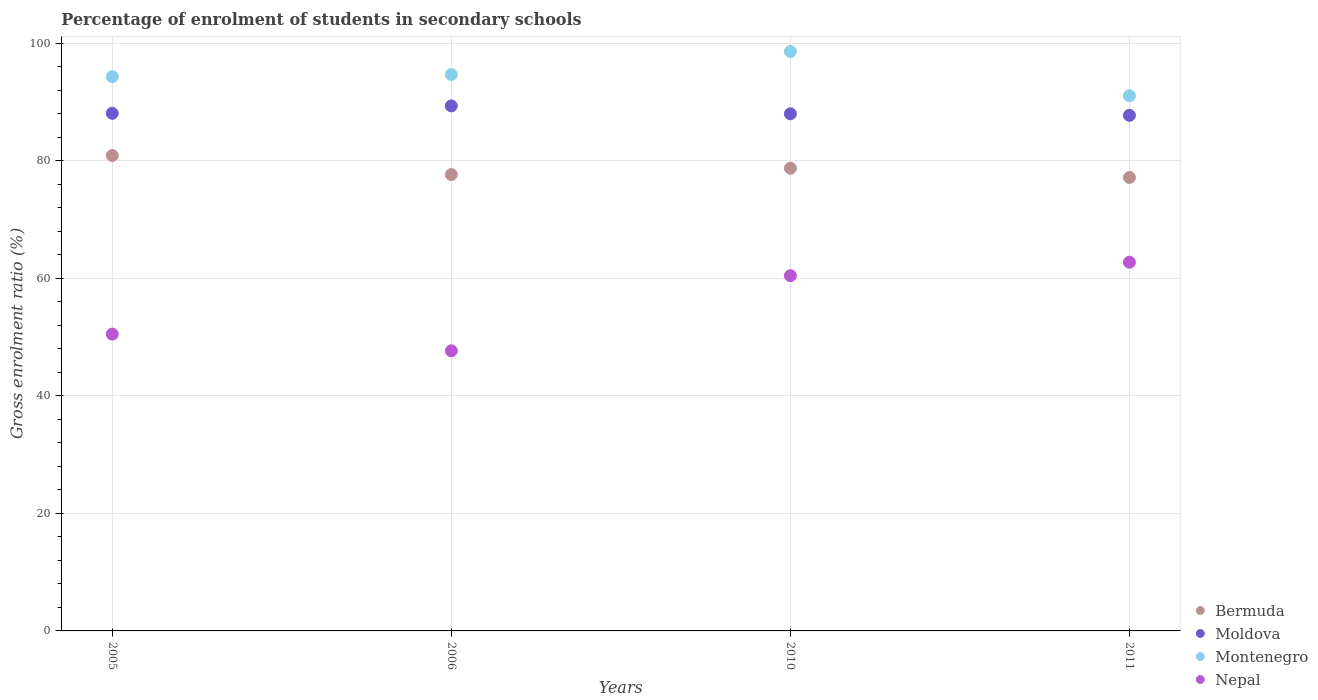How many different coloured dotlines are there?
Your response must be concise. 4. Is the number of dotlines equal to the number of legend labels?
Ensure brevity in your answer.  Yes. What is the percentage of students enrolled in secondary schools in Nepal in 2005?
Your response must be concise. 50.5. Across all years, what is the maximum percentage of students enrolled in secondary schools in Moldova?
Ensure brevity in your answer.  89.32. Across all years, what is the minimum percentage of students enrolled in secondary schools in Moldova?
Your response must be concise. 87.72. In which year was the percentage of students enrolled in secondary schools in Bermuda maximum?
Give a very brief answer. 2005. In which year was the percentage of students enrolled in secondary schools in Montenegro minimum?
Your response must be concise. 2011. What is the total percentage of students enrolled in secondary schools in Nepal in the graph?
Make the answer very short. 221.32. What is the difference between the percentage of students enrolled in secondary schools in Bermuda in 2005 and that in 2006?
Your response must be concise. 3.24. What is the difference between the percentage of students enrolled in secondary schools in Montenegro in 2005 and the percentage of students enrolled in secondary schools in Moldova in 2010?
Ensure brevity in your answer.  6.31. What is the average percentage of students enrolled in secondary schools in Moldova per year?
Offer a very short reply. 88.27. In the year 2005, what is the difference between the percentage of students enrolled in secondary schools in Bermuda and percentage of students enrolled in secondary schools in Nepal?
Ensure brevity in your answer.  30.39. In how many years, is the percentage of students enrolled in secondary schools in Montenegro greater than 52 %?
Your answer should be compact. 4. What is the ratio of the percentage of students enrolled in secondary schools in Moldova in 2006 to that in 2010?
Keep it short and to the point. 1.02. What is the difference between the highest and the second highest percentage of students enrolled in secondary schools in Montenegro?
Your response must be concise. 3.91. What is the difference between the highest and the lowest percentage of students enrolled in secondary schools in Moldova?
Give a very brief answer. 1.6. Is the sum of the percentage of students enrolled in secondary schools in Montenegro in 2005 and 2010 greater than the maximum percentage of students enrolled in secondary schools in Nepal across all years?
Keep it short and to the point. Yes. Is it the case that in every year, the sum of the percentage of students enrolled in secondary schools in Nepal and percentage of students enrolled in secondary schools in Montenegro  is greater than the sum of percentage of students enrolled in secondary schools in Moldova and percentage of students enrolled in secondary schools in Bermuda?
Offer a very short reply. Yes. Is the percentage of students enrolled in secondary schools in Montenegro strictly greater than the percentage of students enrolled in secondary schools in Nepal over the years?
Provide a succinct answer. Yes. What is the difference between two consecutive major ticks on the Y-axis?
Keep it short and to the point. 20. Are the values on the major ticks of Y-axis written in scientific E-notation?
Provide a short and direct response. No. Does the graph contain grids?
Offer a very short reply. Yes. What is the title of the graph?
Keep it short and to the point. Percentage of enrolment of students in secondary schools. Does "Botswana" appear as one of the legend labels in the graph?
Your response must be concise. No. What is the Gross enrolment ratio (%) of Bermuda in 2005?
Your answer should be compact. 80.88. What is the Gross enrolment ratio (%) of Moldova in 2005?
Provide a short and direct response. 88.06. What is the Gross enrolment ratio (%) of Montenegro in 2005?
Offer a terse response. 94.29. What is the Gross enrolment ratio (%) of Nepal in 2005?
Keep it short and to the point. 50.5. What is the Gross enrolment ratio (%) in Bermuda in 2006?
Your answer should be compact. 77.64. What is the Gross enrolment ratio (%) in Moldova in 2006?
Provide a succinct answer. 89.32. What is the Gross enrolment ratio (%) in Montenegro in 2006?
Ensure brevity in your answer.  94.66. What is the Gross enrolment ratio (%) of Nepal in 2006?
Make the answer very short. 47.66. What is the Gross enrolment ratio (%) of Bermuda in 2010?
Offer a very short reply. 78.72. What is the Gross enrolment ratio (%) of Moldova in 2010?
Your answer should be very brief. 87.98. What is the Gross enrolment ratio (%) in Montenegro in 2010?
Provide a succinct answer. 98.57. What is the Gross enrolment ratio (%) in Nepal in 2010?
Keep it short and to the point. 60.44. What is the Gross enrolment ratio (%) of Bermuda in 2011?
Keep it short and to the point. 77.14. What is the Gross enrolment ratio (%) of Moldova in 2011?
Ensure brevity in your answer.  87.72. What is the Gross enrolment ratio (%) of Montenegro in 2011?
Offer a terse response. 91.04. What is the Gross enrolment ratio (%) of Nepal in 2011?
Offer a terse response. 62.73. Across all years, what is the maximum Gross enrolment ratio (%) of Bermuda?
Make the answer very short. 80.88. Across all years, what is the maximum Gross enrolment ratio (%) of Moldova?
Offer a very short reply. 89.32. Across all years, what is the maximum Gross enrolment ratio (%) in Montenegro?
Provide a succinct answer. 98.57. Across all years, what is the maximum Gross enrolment ratio (%) of Nepal?
Provide a short and direct response. 62.73. Across all years, what is the minimum Gross enrolment ratio (%) of Bermuda?
Give a very brief answer. 77.14. Across all years, what is the minimum Gross enrolment ratio (%) of Moldova?
Ensure brevity in your answer.  87.72. Across all years, what is the minimum Gross enrolment ratio (%) of Montenegro?
Provide a succinct answer. 91.04. Across all years, what is the minimum Gross enrolment ratio (%) of Nepal?
Offer a terse response. 47.66. What is the total Gross enrolment ratio (%) in Bermuda in the graph?
Your response must be concise. 314.39. What is the total Gross enrolment ratio (%) in Moldova in the graph?
Offer a terse response. 353.09. What is the total Gross enrolment ratio (%) in Montenegro in the graph?
Give a very brief answer. 378.57. What is the total Gross enrolment ratio (%) in Nepal in the graph?
Offer a terse response. 221.32. What is the difference between the Gross enrolment ratio (%) of Bermuda in 2005 and that in 2006?
Give a very brief answer. 3.24. What is the difference between the Gross enrolment ratio (%) of Moldova in 2005 and that in 2006?
Offer a very short reply. -1.26. What is the difference between the Gross enrolment ratio (%) in Montenegro in 2005 and that in 2006?
Give a very brief answer. -0.38. What is the difference between the Gross enrolment ratio (%) of Nepal in 2005 and that in 2006?
Keep it short and to the point. 2.84. What is the difference between the Gross enrolment ratio (%) in Bermuda in 2005 and that in 2010?
Give a very brief answer. 2.16. What is the difference between the Gross enrolment ratio (%) in Moldova in 2005 and that in 2010?
Offer a terse response. 0.08. What is the difference between the Gross enrolment ratio (%) in Montenegro in 2005 and that in 2010?
Offer a terse response. -4.28. What is the difference between the Gross enrolment ratio (%) in Nepal in 2005 and that in 2010?
Keep it short and to the point. -9.94. What is the difference between the Gross enrolment ratio (%) of Bermuda in 2005 and that in 2011?
Provide a succinct answer. 3.74. What is the difference between the Gross enrolment ratio (%) of Moldova in 2005 and that in 2011?
Your answer should be compact. 0.34. What is the difference between the Gross enrolment ratio (%) in Montenegro in 2005 and that in 2011?
Your answer should be very brief. 3.25. What is the difference between the Gross enrolment ratio (%) of Nepal in 2005 and that in 2011?
Your answer should be compact. -12.23. What is the difference between the Gross enrolment ratio (%) in Bermuda in 2006 and that in 2010?
Your response must be concise. -1.08. What is the difference between the Gross enrolment ratio (%) of Moldova in 2006 and that in 2010?
Give a very brief answer. 1.34. What is the difference between the Gross enrolment ratio (%) of Montenegro in 2006 and that in 2010?
Provide a succinct answer. -3.91. What is the difference between the Gross enrolment ratio (%) of Nepal in 2006 and that in 2010?
Your response must be concise. -12.78. What is the difference between the Gross enrolment ratio (%) in Bermuda in 2006 and that in 2011?
Keep it short and to the point. 0.5. What is the difference between the Gross enrolment ratio (%) in Moldova in 2006 and that in 2011?
Your answer should be compact. 1.6. What is the difference between the Gross enrolment ratio (%) in Montenegro in 2006 and that in 2011?
Offer a very short reply. 3.62. What is the difference between the Gross enrolment ratio (%) in Nepal in 2006 and that in 2011?
Ensure brevity in your answer.  -15.07. What is the difference between the Gross enrolment ratio (%) of Bermuda in 2010 and that in 2011?
Your answer should be compact. 1.58. What is the difference between the Gross enrolment ratio (%) of Moldova in 2010 and that in 2011?
Make the answer very short. 0.26. What is the difference between the Gross enrolment ratio (%) of Montenegro in 2010 and that in 2011?
Give a very brief answer. 7.53. What is the difference between the Gross enrolment ratio (%) of Nepal in 2010 and that in 2011?
Give a very brief answer. -2.29. What is the difference between the Gross enrolment ratio (%) in Bermuda in 2005 and the Gross enrolment ratio (%) in Moldova in 2006?
Give a very brief answer. -8.44. What is the difference between the Gross enrolment ratio (%) in Bermuda in 2005 and the Gross enrolment ratio (%) in Montenegro in 2006?
Make the answer very short. -13.78. What is the difference between the Gross enrolment ratio (%) of Bermuda in 2005 and the Gross enrolment ratio (%) of Nepal in 2006?
Give a very brief answer. 33.23. What is the difference between the Gross enrolment ratio (%) in Moldova in 2005 and the Gross enrolment ratio (%) in Montenegro in 2006?
Offer a very short reply. -6.6. What is the difference between the Gross enrolment ratio (%) of Moldova in 2005 and the Gross enrolment ratio (%) of Nepal in 2006?
Provide a short and direct response. 40.41. What is the difference between the Gross enrolment ratio (%) in Montenegro in 2005 and the Gross enrolment ratio (%) in Nepal in 2006?
Provide a succinct answer. 46.63. What is the difference between the Gross enrolment ratio (%) in Bermuda in 2005 and the Gross enrolment ratio (%) in Moldova in 2010?
Your answer should be very brief. -7.1. What is the difference between the Gross enrolment ratio (%) in Bermuda in 2005 and the Gross enrolment ratio (%) in Montenegro in 2010?
Your answer should be compact. -17.69. What is the difference between the Gross enrolment ratio (%) of Bermuda in 2005 and the Gross enrolment ratio (%) of Nepal in 2010?
Your answer should be very brief. 20.45. What is the difference between the Gross enrolment ratio (%) in Moldova in 2005 and the Gross enrolment ratio (%) in Montenegro in 2010?
Your answer should be very brief. -10.51. What is the difference between the Gross enrolment ratio (%) in Moldova in 2005 and the Gross enrolment ratio (%) in Nepal in 2010?
Ensure brevity in your answer.  27.62. What is the difference between the Gross enrolment ratio (%) of Montenegro in 2005 and the Gross enrolment ratio (%) of Nepal in 2010?
Provide a short and direct response. 33.85. What is the difference between the Gross enrolment ratio (%) of Bermuda in 2005 and the Gross enrolment ratio (%) of Moldova in 2011?
Your answer should be very brief. -6.83. What is the difference between the Gross enrolment ratio (%) in Bermuda in 2005 and the Gross enrolment ratio (%) in Montenegro in 2011?
Your response must be concise. -10.16. What is the difference between the Gross enrolment ratio (%) of Bermuda in 2005 and the Gross enrolment ratio (%) of Nepal in 2011?
Provide a short and direct response. 18.16. What is the difference between the Gross enrolment ratio (%) in Moldova in 2005 and the Gross enrolment ratio (%) in Montenegro in 2011?
Make the answer very short. -2.98. What is the difference between the Gross enrolment ratio (%) of Moldova in 2005 and the Gross enrolment ratio (%) of Nepal in 2011?
Keep it short and to the point. 25.33. What is the difference between the Gross enrolment ratio (%) in Montenegro in 2005 and the Gross enrolment ratio (%) in Nepal in 2011?
Ensure brevity in your answer.  31.56. What is the difference between the Gross enrolment ratio (%) of Bermuda in 2006 and the Gross enrolment ratio (%) of Moldova in 2010?
Your answer should be compact. -10.34. What is the difference between the Gross enrolment ratio (%) of Bermuda in 2006 and the Gross enrolment ratio (%) of Montenegro in 2010?
Offer a terse response. -20.93. What is the difference between the Gross enrolment ratio (%) of Bermuda in 2006 and the Gross enrolment ratio (%) of Nepal in 2010?
Ensure brevity in your answer.  17.2. What is the difference between the Gross enrolment ratio (%) in Moldova in 2006 and the Gross enrolment ratio (%) in Montenegro in 2010?
Provide a short and direct response. -9.25. What is the difference between the Gross enrolment ratio (%) in Moldova in 2006 and the Gross enrolment ratio (%) in Nepal in 2010?
Offer a very short reply. 28.88. What is the difference between the Gross enrolment ratio (%) in Montenegro in 2006 and the Gross enrolment ratio (%) in Nepal in 2010?
Provide a succinct answer. 34.23. What is the difference between the Gross enrolment ratio (%) in Bermuda in 2006 and the Gross enrolment ratio (%) in Moldova in 2011?
Give a very brief answer. -10.08. What is the difference between the Gross enrolment ratio (%) in Bermuda in 2006 and the Gross enrolment ratio (%) in Montenegro in 2011?
Offer a terse response. -13.4. What is the difference between the Gross enrolment ratio (%) in Bermuda in 2006 and the Gross enrolment ratio (%) in Nepal in 2011?
Make the answer very short. 14.91. What is the difference between the Gross enrolment ratio (%) in Moldova in 2006 and the Gross enrolment ratio (%) in Montenegro in 2011?
Ensure brevity in your answer.  -1.72. What is the difference between the Gross enrolment ratio (%) of Moldova in 2006 and the Gross enrolment ratio (%) of Nepal in 2011?
Offer a very short reply. 26.59. What is the difference between the Gross enrolment ratio (%) of Montenegro in 2006 and the Gross enrolment ratio (%) of Nepal in 2011?
Your answer should be very brief. 31.94. What is the difference between the Gross enrolment ratio (%) in Bermuda in 2010 and the Gross enrolment ratio (%) in Moldova in 2011?
Provide a short and direct response. -9. What is the difference between the Gross enrolment ratio (%) of Bermuda in 2010 and the Gross enrolment ratio (%) of Montenegro in 2011?
Provide a succinct answer. -12.32. What is the difference between the Gross enrolment ratio (%) of Bermuda in 2010 and the Gross enrolment ratio (%) of Nepal in 2011?
Make the answer very short. 16. What is the difference between the Gross enrolment ratio (%) in Moldova in 2010 and the Gross enrolment ratio (%) in Montenegro in 2011?
Make the answer very short. -3.06. What is the difference between the Gross enrolment ratio (%) of Moldova in 2010 and the Gross enrolment ratio (%) of Nepal in 2011?
Ensure brevity in your answer.  25.25. What is the difference between the Gross enrolment ratio (%) of Montenegro in 2010 and the Gross enrolment ratio (%) of Nepal in 2011?
Give a very brief answer. 35.84. What is the average Gross enrolment ratio (%) in Bermuda per year?
Ensure brevity in your answer.  78.6. What is the average Gross enrolment ratio (%) of Moldova per year?
Your response must be concise. 88.27. What is the average Gross enrolment ratio (%) of Montenegro per year?
Your answer should be very brief. 94.64. What is the average Gross enrolment ratio (%) of Nepal per year?
Your response must be concise. 55.33. In the year 2005, what is the difference between the Gross enrolment ratio (%) in Bermuda and Gross enrolment ratio (%) in Moldova?
Offer a terse response. -7.18. In the year 2005, what is the difference between the Gross enrolment ratio (%) of Bermuda and Gross enrolment ratio (%) of Montenegro?
Ensure brevity in your answer.  -13.4. In the year 2005, what is the difference between the Gross enrolment ratio (%) in Bermuda and Gross enrolment ratio (%) in Nepal?
Provide a short and direct response. 30.39. In the year 2005, what is the difference between the Gross enrolment ratio (%) in Moldova and Gross enrolment ratio (%) in Montenegro?
Your answer should be compact. -6.23. In the year 2005, what is the difference between the Gross enrolment ratio (%) of Moldova and Gross enrolment ratio (%) of Nepal?
Keep it short and to the point. 37.57. In the year 2005, what is the difference between the Gross enrolment ratio (%) of Montenegro and Gross enrolment ratio (%) of Nepal?
Provide a short and direct response. 43.79. In the year 2006, what is the difference between the Gross enrolment ratio (%) of Bermuda and Gross enrolment ratio (%) of Moldova?
Offer a terse response. -11.68. In the year 2006, what is the difference between the Gross enrolment ratio (%) of Bermuda and Gross enrolment ratio (%) of Montenegro?
Keep it short and to the point. -17.02. In the year 2006, what is the difference between the Gross enrolment ratio (%) of Bermuda and Gross enrolment ratio (%) of Nepal?
Your answer should be very brief. 29.99. In the year 2006, what is the difference between the Gross enrolment ratio (%) of Moldova and Gross enrolment ratio (%) of Montenegro?
Your response must be concise. -5.34. In the year 2006, what is the difference between the Gross enrolment ratio (%) of Moldova and Gross enrolment ratio (%) of Nepal?
Keep it short and to the point. 41.67. In the year 2006, what is the difference between the Gross enrolment ratio (%) in Montenegro and Gross enrolment ratio (%) in Nepal?
Give a very brief answer. 47.01. In the year 2010, what is the difference between the Gross enrolment ratio (%) in Bermuda and Gross enrolment ratio (%) in Moldova?
Make the answer very short. -9.26. In the year 2010, what is the difference between the Gross enrolment ratio (%) of Bermuda and Gross enrolment ratio (%) of Montenegro?
Ensure brevity in your answer.  -19.85. In the year 2010, what is the difference between the Gross enrolment ratio (%) in Bermuda and Gross enrolment ratio (%) in Nepal?
Your answer should be very brief. 18.29. In the year 2010, what is the difference between the Gross enrolment ratio (%) in Moldova and Gross enrolment ratio (%) in Montenegro?
Give a very brief answer. -10.59. In the year 2010, what is the difference between the Gross enrolment ratio (%) in Moldova and Gross enrolment ratio (%) in Nepal?
Your answer should be compact. 27.54. In the year 2010, what is the difference between the Gross enrolment ratio (%) of Montenegro and Gross enrolment ratio (%) of Nepal?
Make the answer very short. 38.13. In the year 2011, what is the difference between the Gross enrolment ratio (%) in Bermuda and Gross enrolment ratio (%) in Moldova?
Offer a very short reply. -10.58. In the year 2011, what is the difference between the Gross enrolment ratio (%) of Bermuda and Gross enrolment ratio (%) of Montenegro?
Provide a short and direct response. -13.9. In the year 2011, what is the difference between the Gross enrolment ratio (%) of Bermuda and Gross enrolment ratio (%) of Nepal?
Make the answer very short. 14.41. In the year 2011, what is the difference between the Gross enrolment ratio (%) of Moldova and Gross enrolment ratio (%) of Montenegro?
Your answer should be very brief. -3.32. In the year 2011, what is the difference between the Gross enrolment ratio (%) in Moldova and Gross enrolment ratio (%) in Nepal?
Your answer should be very brief. 24.99. In the year 2011, what is the difference between the Gross enrolment ratio (%) in Montenegro and Gross enrolment ratio (%) in Nepal?
Make the answer very short. 28.31. What is the ratio of the Gross enrolment ratio (%) in Bermuda in 2005 to that in 2006?
Your answer should be compact. 1.04. What is the ratio of the Gross enrolment ratio (%) in Moldova in 2005 to that in 2006?
Your answer should be compact. 0.99. What is the ratio of the Gross enrolment ratio (%) in Montenegro in 2005 to that in 2006?
Your response must be concise. 1. What is the ratio of the Gross enrolment ratio (%) of Nepal in 2005 to that in 2006?
Ensure brevity in your answer.  1.06. What is the ratio of the Gross enrolment ratio (%) of Bermuda in 2005 to that in 2010?
Give a very brief answer. 1.03. What is the ratio of the Gross enrolment ratio (%) in Moldova in 2005 to that in 2010?
Your answer should be compact. 1. What is the ratio of the Gross enrolment ratio (%) of Montenegro in 2005 to that in 2010?
Provide a short and direct response. 0.96. What is the ratio of the Gross enrolment ratio (%) of Nepal in 2005 to that in 2010?
Provide a succinct answer. 0.84. What is the ratio of the Gross enrolment ratio (%) in Bermuda in 2005 to that in 2011?
Your answer should be very brief. 1.05. What is the ratio of the Gross enrolment ratio (%) of Montenegro in 2005 to that in 2011?
Your answer should be very brief. 1.04. What is the ratio of the Gross enrolment ratio (%) of Nepal in 2005 to that in 2011?
Provide a short and direct response. 0.81. What is the ratio of the Gross enrolment ratio (%) in Bermuda in 2006 to that in 2010?
Your answer should be very brief. 0.99. What is the ratio of the Gross enrolment ratio (%) of Moldova in 2006 to that in 2010?
Offer a terse response. 1.02. What is the ratio of the Gross enrolment ratio (%) in Montenegro in 2006 to that in 2010?
Offer a very short reply. 0.96. What is the ratio of the Gross enrolment ratio (%) of Nepal in 2006 to that in 2010?
Provide a succinct answer. 0.79. What is the ratio of the Gross enrolment ratio (%) of Bermuda in 2006 to that in 2011?
Your answer should be very brief. 1.01. What is the ratio of the Gross enrolment ratio (%) in Moldova in 2006 to that in 2011?
Provide a succinct answer. 1.02. What is the ratio of the Gross enrolment ratio (%) of Montenegro in 2006 to that in 2011?
Your response must be concise. 1.04. What is the ratio of the Gross enrolment ratio (%) in Nepal in 2006 to that in 2011?
Offer a very short reply. 0.76. What is the ratio of the Gross enrolment ratio (%) in Bermuda in 2010 to that in 2011?
Ensure brevity in your answer.  1.02. What is the ratio of the Gross enrolment ratio (%) of Montenegro in 2010 to that in 2011?
Keep it short and to the point. 1.08. What is the ratio of the Gross enrolment ratio (%) of Nepal in 2010 to that in 2011?
Ensure brevity in your answer.  0.96. What is the difference between the highest and the second highest Gross enrolment ratio (%) of Bermuda?
Your answer should be compact. 2.16. What is the difference between the highest and the second highest Gross enrolment ratio (%) in Moldova?
Ensure brevity in your answer.  1.26. What is the difference between the highest and the second highest Gross enrolment ratio (%) of Montenegro?
Ensure brevity in your answer.  3.91. What is the difference between the highest and the second highest Gross enrolment ratio (%) of Nepal?
Offer a terse response. 2.29. What is the difference between the highest and the lowest Gross enrolment ratio (%) of Bermuda?
Your answer should be compact. 3.74. What is the difference between the highest and the lowest Gross enrolment ratio (%) in Moldova?
Give a very brief answer. 1.6. What is the difference between the highest and the lowest Gross enrolment ratio (%) of Montenegro?
Your answer should be compact. 7.53. What is the difference between the highest and the lowest Gross enrolment ratio (%) of Nepal?
Offer a very short reply. 15.07. 